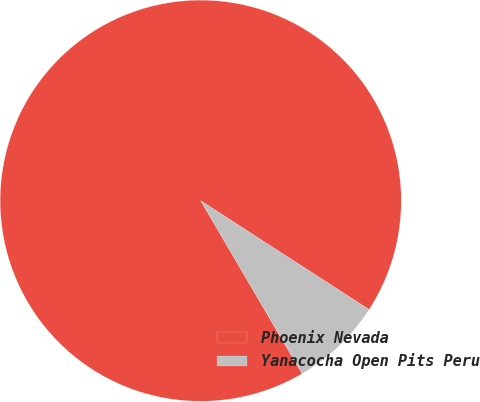Convert chart. <chart><loc_0><loc_0><loc_500><loc_500><pie_chart><fcel>Phoenix Nevada<fcel>Yanacocha Open Pits Peru<nl><fcel>92.57%<fcel>7.43%<nl></chart> 